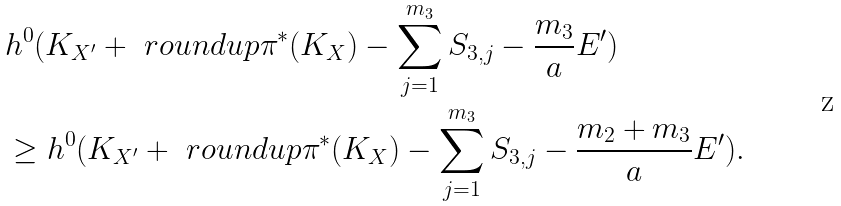Convert formula to latex. <formula><loc_0><loc_0><loc_500><loc_500>& h ^ { 0 } ( K _ { X ^ { \prime } } + \ r o u n d u p { \pi ^ { * } ( K _ { X } ) - \sum _ { j = 1 } ^ { m _ { 3 } } S _ { 3 , j } - \frac { m _ { 3 } } { a } E ^ { \prime } } ) \\ & \geq h ^ { 0 } ( K _ { X ^ { \prime } } + \ r o u n d u p { \pi ^ { * } ( K _ { X } ) - \sum _ { j = 1 } ^ { m _ { 3 } } S _ { 3 , j } - \frac { m _ { 2 } + m _ { 3 } } { a } E ^ { \prime } } ) .</formula> 